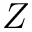Convert formula to latex. <formula><loc_0><loc_0><loc_500><loc_500>Z</formula> 